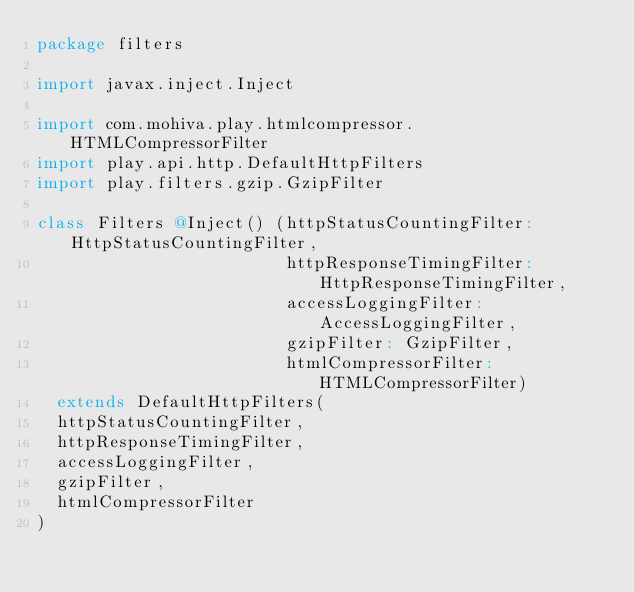<code> <loc_0><loc_0><loc_500><loc_500><_Scala_>package filters

import javax.inject.Inject

import com.mohiva.play.htmlcompressor.HTMLCompressorFilter
import play.api.http.DefaultHttpFilters
import play.filters.gzip.GzipFilter

class Filters @Inject() (httpStatusCountingFilter: HttpStatusCountingFilter,
                         httpResponseTimingFilter: HttpResponseTimingFilter,
                         accessLoggingFilter: AccessLoggingFilter,
                         gzipFilter: GzipFilter,
                         htmlCompressorFilter: HTMLCompressorFilter)
  extends DefaultHttpFilters(
  httpStatusCountingFilter,
  httpResponseTimingFilter,
  accessLoggingFilter,
  gzipFilter,
  htmlCompressorFilter
)
</code> 